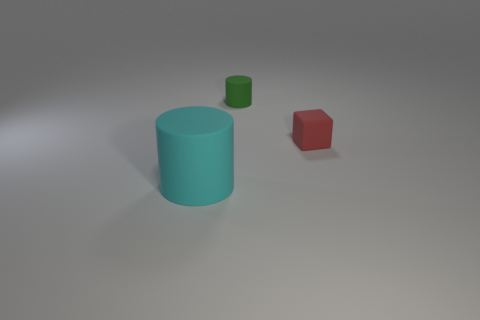What is the shape of the tiny green rubber object?
Your answer should be very brief. Cylinder. Is the small thing that is left of the red matte block made of the same material as the object that is in front of the small red matte block?
Keep it short and to the point. Yes. What is the shape of the thing that is on the left side of the red matte object and in front of the tiny green rubber cylinder?
Keep it short and to the point. Cylinder. There is a object that is in front of the small matte cylinder and left of the small red rubber block; what color is it?
Provide a succinct answer. Cyan. Is the number of tiny matte objects to the right of the small green matte cylinder greater than the number of green rubber objects in front of the big rubber cylinder?
Provide a short and direct response. Yes. The rubber cylinder that is behind the red thing is what color?
Provide a short and direct response. Green. Does the tiny rubber object behind the tiny rubber block have the same shape as the small rubber thing that is in front of the small green object?
Your answer should be very brief. No. Are there any matte cubes that have the same size as the cyan cylinder?
Your answer should be compact. No. What material is the cylinder that is on the right side of the big cyan object?
Provide a short and direct response. Rubber. Is the material of the thing behind the red thing the same as the cyan object?
Provide a succinct answer. Yes. 